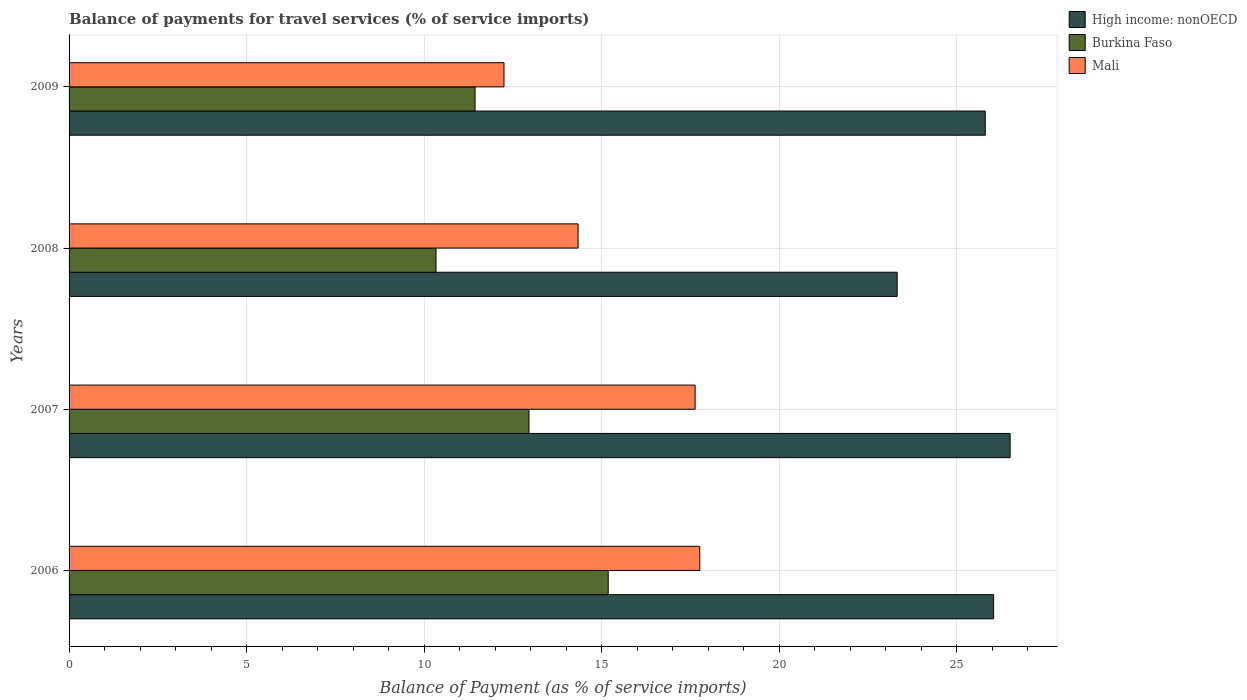How many different coloured bars are there?
Your answer should be very brief. 3. Are the number of bars on each tick of the Y-axis equal?
Provide a short and direct response. Yes. In how many cases, is the number of bars for a given year not equal to the number of legend labels?
Provide a succinct answer. 0. What is the balance of payments for travel services in Mali in 2008?
Provide a short and direct response. 14.34. Across all years, what is the maximum balance of payments for travel services in Mali?
Keep it short and to the point. 17.76. Across all years, what is the minimum balance of payments for travel services in Burkina Faso?
Make the answer very short. 10.33. What is the total balance of payments for travel services in Mali in the graph?
Make the answer very short. 61.98. What is the difference between the balance of payments for travel services in Mali in 2006 and that in 2009?
Make the answer very short. 5.51. What is the difference between the balance of payments for travel services in Mali in 2006 and the balance of payments for travel services in High income: nonOECD in 2007?
Give a very brief answer. -8.74. What is the average balance of payments for travel services in Mali per year?
Your answer should be very brief. 15.49. In the year 2008, what is the difference between the balance of payments for travel services in Mali and balance of payments for travel services in High income: nonOECD?
Offer a very short reply. -8.99. What is the ratio of the balance of payments for travel services in Burkina Faso in 2006 to that in 2007?
Offer a very short reply. 1.17. Is the balance of payments for travel services in Burkina Faso in 2006 less than that in 2009?
Provide a short and direct response. No. What is the difference between the highest and the second highest balance of payments for travel services in High income: nonOECD?
Provide a succinct answer. 0.47. What is the difference between the highest and the lowest balance of payments for travel services in Mali?
Your answer should be compact. 5.51. In how many years, is the balance of payments for travel services in High income: nonOECD greater than the average balance of payments for travel services in High income: nonOECD taken over all years?
Keep it short and to the point. 3. Is the sum of the balance of payments for travel services in Burkina Faso in 2006 and 2008 greater than the maximum balance of payments for travel services in High income: nonOECD across all years?
Your response must be concise. No. What does the 3rd bar from the top in 2008 represents?
Give a very brief answer. High income: nonOECD. What does the 2nd bar from the bottom in 2007 represents?
Make the answer very short. Burkina Faso. Are all the bars in the graph horizontal?
Provide a succinct answer. Yes. What is the difference between two consecutive major ticks on the X-axis?
Provide a short and direct response. 5. Are the values on the major ticks of X-axis written in scientific E-notation?
Provide a short and direct response. No. Does the graph contain grids?
Give a very brief answer. Yes. Where does the legend appear in the graph?
Offer a terse response. Top right. What is the title of the graph?
Make the answer very short. Balance of payments for travel services (% of service imports). What is the label or title of the X-axis?
Keep it short and to the point. Balance of Payment (as % of service imports). What is the Balance of Payment (as % of service imports) in High income: nonOECD in 2006?
Provide a short and direct response. 26.04. What is the Balance of Payment (as % of service imports) in Burkina Faso in 2006?
Offer a terse response. 15.18. What is the Balance of Payment (as % of service imports) in Mali in 2006?
Offer a terse response. 17.76. What is the Balance of Payment (as % of service imports) of High income: nonOECD in 2007?
Ensure brevity in your answer.  26.5. What is the Balance of Payment (as % of service imports) of Burkina Faso in 2007?
Provide a short and direct response. 12.95. What is the Balance of Payment (as % of service imports) in Mali in 2007?
Provide a succinct answer. 17.63. What is the Balance of Payment (as % of service imports) in High income: nonOECD in 2008?
Your answer should be compact. 23.32. What is the Balance of Payment (as % of service imports) of Burkina Faso in 2008?
Offer a terse response. 10.33. What is the Balance of Payment (as % of service imports) of Mali in 2008?
Your response must be concise. 14.34. What is the Balance of Payment (as % of service imports) in High income: nonOECD in 2009?
Keep it short and to the point. 25.8. What is the Balance of Payment (as % of service imports) in Burkina Faso in 2009?
Your response must be concise. 11.43. What is the Balance of Payment (as % of service imports) of Mali in 2009?
Make the answer very short. 12.25. Across all years, what is the maximum Balance of Payment (as % of service imports) in High income: nonOECD?
Keep it short and to the point. 26.5. Across all years, what is the maximum Balance of Payment (as % of service imports) in Burkina Faso?
Make the answer very short. 15.18. Across all years, what is the maximum Balance of Payment (as % of service imports) in Mali?
Ensure brevity in your answer.  17.76. Across all years, what is the minimum Balance of Payment (as % of service imports) in High income: nonOECD?
Provide a succinct answer. 23.32. Across all years, what is the minimum Balance of Payment (as % of service imports) of Burkina Faso?
Keep it short and to the point. 10.33. Across all years, what is the minimum Balance of Payment (as % of service imports) of Mali?
Keep it short and to the point. 12.25. What is the total Balance of Payment (as % of service imports) in High income: nonOECD in the graph?
Keep it short and to the point. 101.66. What is the total Balance of Payment (as % of service imports) of Burkina Faso in the graph?
Keep it short and to the point. 49.9. What is the total Balance of Payment (as % of service imports) in Mali in the graph?
Your response must be concise. 61.98. What is the difference between the Balance of Payment (as % of service imports) of High income: nonOECD in 2006 and that in 2007?
Provide a succinct answer. -0.47. What is the difference between the Balance of Payment (as % of service imports) of Burkina Faso in 2006 and that in 2007?
Provide a short and direct response. 2.23. What is the difference between the Balance of Payment (as % of service imports) of Mali in 2006 and that in 2007?
Offer a very short reply. 0.13. What is the difference between the Balance of Payment (as % of service imports) of High income: nonOECD in 2006 and that in 2008?
Ensure brevity in your answer.  2.72. What is the difference between the Balance of Payment (as % of service imports) in Burkina Faso in 2006 and that in 2008?
Provide a short and direct response. 4.85. What is the difference between the Balance of Payment (as % of service imports) of Mali in 2006 and that in 2008?
Your answer should be compact. 3.43. What is the difference between the Balance of Payment (as % of service imports) of High income: nonOECD in 2006 and that in 2009?
Keep it short and to the point. 0.23. What is the difference between the Balance of Payment (as % of service imports) in Burkina Faso in 2006 and that in 2009?
Your response must be concise. 3.75. What is the difference between the Balance of Payment (as % of service imports) of Mali in 2006 and that in 2009?
Offer a terse response. 5.51. What is the difference between the Balance of Payment (as % of service imports) of High income: nonOECD in 2007 and that in 2008?
Make the answer very short. 3.18. What is the difference between the Balance of Payment (as % of service imports) of Burkina Faso in 2007 and that in 2008?
Your answer should be very brief. 2.62. What is the difference between the Balance of Payment (as % of service imports) of Mali in 2007 and that in 2008?
Your answer should be compact. 3.3. What is the difference between the Balance of Payment (as % of service imports) of High income: nonOECD in 2007 and that in 2009?
Keep it short and to the point. 0.7. What is the difference between the Balance of Payment (as % of service imports) in Burkina Faso in 2007 and that in 2009?
Keep it short and to the point. 1.52. What is the difference between the Balance of Payment (as % of service imports) in Mali in 2007 and that in 2009?
Your response must be concise. 5.38. What is the difference between the Balance of Payment (as % of service imports) of High income: nonOECD in 2008 and that in 2009?
Offer a very short reply. -2.48. What is the difference between the Balance of Payment (as % of service imports) in Burkina Faso in 2008 and that in 2009?
Ensure brevity in your answer.  -1.1. What is the difference between the Balance of Payment (as % of service imports) in Mali in 2008 and that in 2009?
Keep it short and to the point. 2.09. What is the difference between the Balance of Payment (as % of service imports) of High income: nonOECD in 2006 and the Balance of Payment (as % of service imports) of Burkina Faso in 2007?
Offer a terse response. 13.08. What is the difference between the Balance of Payment (as % of service imports) in High income: nonOECD in 2006 and the Balance of Payment (as % of service imports) in Mali in 2007?
Ensure brevity in your answer.  8.41. What is the difference between the Balance of Payment (as % of service imports) of Burkina Faso in 2006 and the Balance of Payment (as % of service imports) of Mali in 2007?
Keep it short and to the point. -2.45. What is the difference between the Balance of Payment (as % of service imports) in High income: nonOECD in 2006 and the Balance of Payment (as % of service imports) in Burkina Faso in 2008?
Your response must be concise. 15.7. What is the difference between the Balance of Payment (as % of service imports) in High income: nonOECD in 2006 and the Balance of Payment (as % of service imports) in Mali in 2008?
Provide a succinct answer. 11.7. What is the difference between the Balance of Payment (as % of service imports) in Burkina Faso in 2006 and the Balance of Payment (as % of service imports) in Mali in 2008?
Make the answer very short. 0.85. What is the difference between the Balance of Payment (as % of service imports) of High income: nonOECD in 2006 and the Balance of Payment (as % of service imports) of Burkina Faso in 2009?
Provide a succinct answer. 14.6. What is the difference between the Balance of Payment (as % of service imports) in High income: nonOECD in 2006 and the Balance of Payment (as % of service imports) in Mali in 2009?
Keep it short and to the point. 13.79. What is the difference between the Balance of Payment (as % of service imports) of Burkina Faso in 2006 and the Balance of Payment (as % of service imports) of Mali in 2009?
Ensure brevity in your answer.  2.94. What is the difference between the Balance of Payment (as % of service imports) of High income: nonOECD in 2007 and the Balance of Payment (as % of service imports) of Burkina Faso in 2008?
Ensure brevity in your answer.  16.17. What is the difference between the Balance of Payment (as % of service imports) of High income: nonOECD in 2007 and the Balance of Payment (as % of service imports) of Mali in 2008?
Provide a short and direct response. 12.17. What is the difference between the Balance of Payment (as % of service imports) of Burkina Faso in 2007 and the Balance of Payment (as % of service imports) of Mali in 2008?
Your answer should be very brief. -1.38. What is the difference between the Balance of Payment (as % of service imports) of High income: nonOECD in 2007 and the Balance of Payment (as % of service imports) of Burkina Faso in 2009?
Ensure brevity in your answer.  15.07. What is the difference between the Balance of Payment (as % of service imports) in High income: nonOECD in 2007 and the Balance of Payment (as % of service imports) in Mali in 2009?
Make the answer very short. 14.25. What is the difference between the Balance of Payment (as % of service imports) in Burkina Faso in 2007 and the Balance of Payment (as % of service imports) in Mali in 2009?
Your response must be concise. 0.7. What is the difference between the Balance of Payment (as % of service imports) of High income: nonOECD in 2008 and the Balance of Payment (as % of service imports) of Burkina Faso in 2009?
Provide a succinct answer. 11.89. What is the difference between the Balance of Payment (as % of service imports) in High income: nonOECD in 2008 and the Balance of Payment (as % of service imports) in Mali in 2009?
Provide a succinct answer. 11.07. What is the difference between the Balance of Payment (as % of service imports) of Burkina Faso in 2008 and the Balance of Payment (as % of service imports) of Mali in 2009?
Keep it short and to the point. -1.91. What is the average Balance of Payment (as % of service imports) of High income: nonOECD per year?
Provide a succinct answer. 25.42. What is the average Balance of Payment (as % of service imports) in Burkina Faso per year?
Keep it short and to the point. 12.48. What is the average Balance of Payment (as % of service imports) in Mali per year?
Offer a very short reply. 15.49. In the year 2006, what is the difference between the Balance of Payment (as % of service imports) in High income: nonOECD and Balance of Payment (as % of service imports) in Burkina Faso?
Offer a very short reply. 10.85. In the year 2006, what is the difference between the Balance of Payment (as % of service imports) of High income: nonOECD and Balance of Payment (as % of service imports) of Mali?
Provide a short and direct response. 8.28. In the year 2006, what is the difference between the Balance of Payment (as % of service imports) in Burkina Faso and Balance of Payment (as % of service imports) in Mali?
Keep it short and to the point. -2.58. In the year 2007, what is the difference between the Balance of Payment (as % of service imports) in High income: nonOECD and Balance of Payment (as % of service imports) in Burkina Faso?
Your answer should be compact. 13.55. In the year 2007, what is the difference between the Balance of Payment (as % of service imports) of High income: nonOECD and Balance of Payment (as % of service imports) of Mali?
Make the answer very short. 8.87. In the year 2007, what is the difference between the Balance of Payment (as % of service imports) of Burkina Faso and Balance of Payment (as % of service imports) of Mali?
Provide a succinct answer. -4.68. In the year 2008, what is the difference between the Balance of Payment (as % of service imports) in High income: nonOECD and Balance of Payment (as % of service imports) in Burkina Faso?
Offer a terse response. 12.99. In the year 2008, what is the difference between the Balance of Payment (as % of service imports) in High income: nonOECD and Balance of Payment (as % of service imports) in Mali?
Your answer should be compact. 8.99. In the year 2008, what is the difference between the Balance of Payment (as % of service imports) in Burkina Faso and Balance of Payment (as % of service imports) in Mali?
Keep it short and to the point. -4. In the year 2009, what is the difference between the Balance of Payment (as % of service imports) of High income: nonOECD and Balance of Payment (as % of service imports) of Burkina Faso?
Keep it short and to the point. 14.37. In the year 2009, what is the difference between the Balance of Payment (as % of service imports) of High income: nonOECD and Balance of Payment (as % of service imports) of Mali?
Offer a terse response. 13.55. In the year 2009, what is the difference between the Balance of Payment (as % of service imports) of Burkina Faso and Balance of Payment (as % of service imports) of Mali?
Keep it short and to the point. -0.81. What is the ratio of the Balance of Payment (as % of service imports) in High income: nonOECD in 2006 to that in 2007?
Your answer should be very brief. 0.98. What is the ratio of the Balance of Payment (as % of service imports) of Burkina Faso in 2006 to that in 2007?
Your response must be concise. 1.17. What is the ratio of the Balance of Payment (as % of service imports) of Mali in 2006 to that in 2007?
Provide a short and direct response. 1.01. What is the ratio of the Balance of Payment (as % of service imports) in High income: nonOECD in 2006 to that in 2008?
Make the answer very short. 1.12. What is the ratio of the Balance of Payment (as % of service imports) in Burkina Faso in 2006 to that in 2008?
Make the answer very short. 1.47. What is the ratio of the Balance of Payment (as % of service imports) of Mali in 2006 to that in 2008?
Provide a succinct answer. 1.24. What is the ratio of the Balance of Payment (as % of service imports) of High income: nonOECD in 2006 to that in 2009?
Ensure brevity in your answer.  1.01. What is the ratio of the Balance of Payment (as % of service imports) of Burkina Faso in 2006 to that in 2009?
Your answer should be very brief. 1.33. What is the ratio of the Balance of Payment (as % of service imports) of Mali in 2006 to that in 2009?
Your answer should be very brief. 1.45. What is the ratio of the Balance of Payment (as % of service imports) of High income: nonOECD in 2007 to that in 2008?
Keep it short and to the point. 1.14. What is the ratio of the Balance of Payment (as % of service imports) of Burkina Faso in 2007 to that in 2008?
Keep it short and to the point. 1.25. What is the ratio of the Balance of Payment (as % of service imports) of Mali in 2007 to that in 2008?
Offer a very short reply. 1.23. What is the ratio of the Balance of Payment (as % of service imports) in High income: nonOECD in 2007 to that in 2009?
Keep it short and to the point. 1.03. What is the ratio of the Balance of Payment (as % of service imports) of Burkina Faso in 2007 to that in 2009?
Your response must be concise. 1.13. What is the ratio of the Balance of Payment (as % of service imports) in Mali in 2007 to that in 2009?
Offer a very short reply. 1.44. What is the ratio of the Balance of Payment (as % of service imports) of High income: nonOECD in 2008 to that in 2009?
Make the answer very short. 0.9. What is the ratio of the Balance of Payment (as % of service imports) of Burkina Faso in 2008 to that in 2009?
Offer a terse response. 0.9. What is the ratio of the Balance of Payment (as % of service imports) of Mali in 2008 to that in 2009?
Make the answer very short. 1.17. What is the difference between the highest and the second highest Balance of Payment (as % of service imports) of High income: nonOECD?
Provide a succinct answer. 0.47. What is the difference between the highest and the second highest Balance of Payment (as % of service imports) of Burkina Faso?
Ensure brevity in your answer.  2.23. What is the difference between the highest and the second highest Balance of Payment (as % of service imports) in Mali?
Give a very brief answer. 0.13. What is the difference between the highest and the lowest Balance of Payment (as % of service imports) in High income: nonOECD?
Offer a terse response. 3.18. What is the difference between the highest and the lowest Balance of Payment (as % of service imports) in Burkina Faso?
Keep it short and to the point. 4.85. What is the difference between the highest and the lowest Balance of Payment (as % of service imports) of Mali?
Your answer should be very brief. 5.51. 